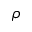Convert formula to latex. <formula><loc_0><loc_0><loc_500><loc_500>\rho</formula> 